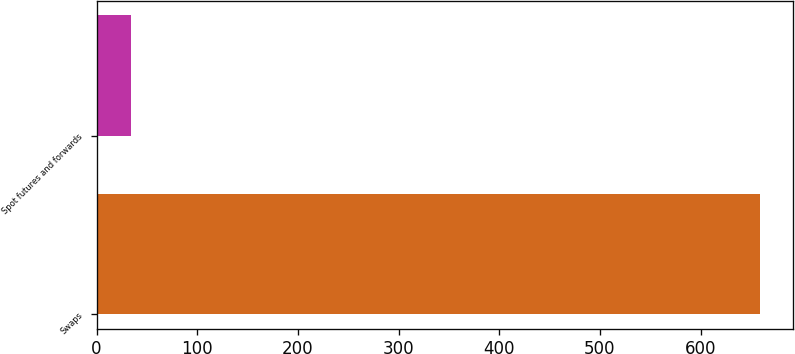<chart> <loc_0><loc_0><loc_500><loc_500><bar_chart><fcel>Swaps<fcel>Spot futures and forwards<nl><fcel>659.3<fcel>34.6<nl></chart> 